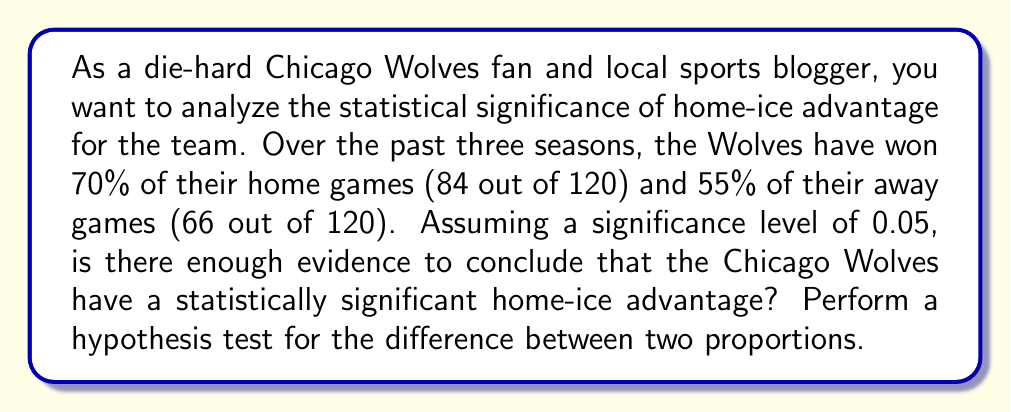Help me with this question. To determine if there's a statistically significant home-ice advantage, we'll conduct a hypothesis test for the difference between two proportions.

Step 1: State the hypotheses
$H_0: p_1 - p_2 = 0$ (No difference in win proportions)
$H_a: p_1 - p_2 > 0$ (Home win proportion is greater)

Where $p_1$ is the proportion of home wins and $p_2$ is the proportion of away wins.

Step 2: Calculate the sample proportions
$\hat{p}_1 = 84/120 = 0.70$ (home)
$\hat{p}_2 = 66/120 = 0.55$ (away)

Step 3: Calculate the pooled proportion
$$\hat{p} = \frac{X_1 + X_2}{n_1 + n_2} = \frac{84 + 66}{120 + 120} = \frac{150}{240} = 0.625$$

Step 4: Calculate the standard error
$$SE = \sqrt{\hat{p}(1-\hat{p})(\frac{1}{n_1} + \frac{1}{n_2})}$$
$$SE = \sqrt{0.625(1-0.625)(\frac{1}{120} + \frac{1}{120})} = 0.0624$$

Step 5: Calculate the test statistic
$$z = \frac{(\hat{p}_1 - \hat{p}_2) - 0}{SE} = \frac{0.70 - 0.55}{0.0624} = 2.40$$

Step 6: Find the p-value
For a one-tailed test, p-value = $P(Z > 2.40)$
Using a standard normal table or calculator, we find:
p-value $\approx 0.0082$

Step 7: Compare the p-value to the significance level
Since 0.0082 < 0.05, we reject the null hypothesis.
Answer: There is enough evidence to conclude that the Chicago Wolves have a statistically significant home-ice advantage (p-value = 0.0082 < 0.05). 